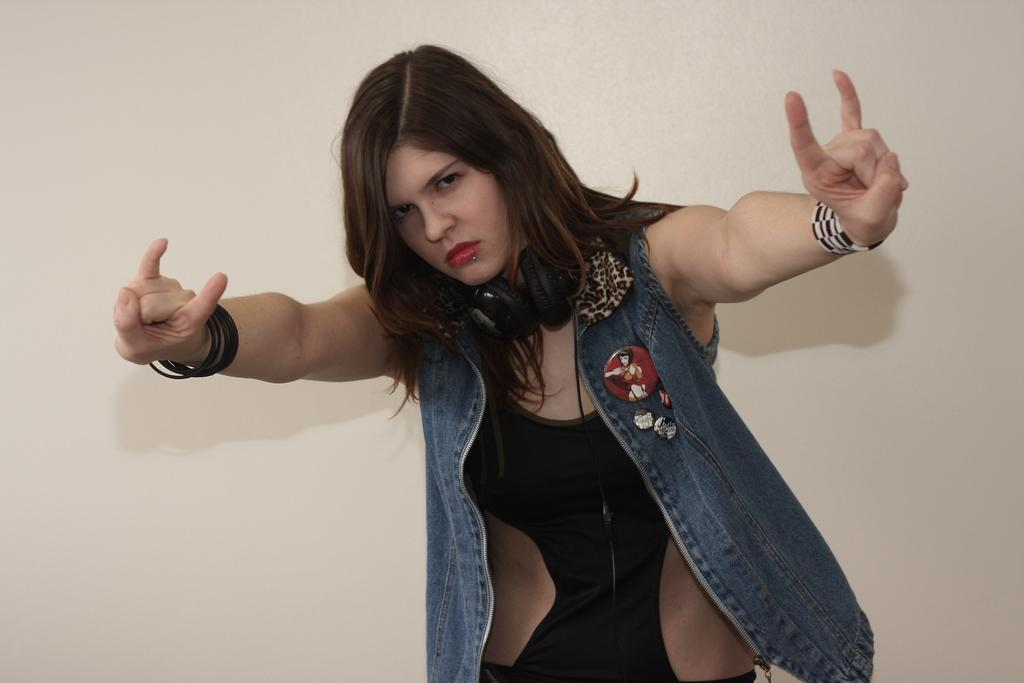Who is the main subject in the image? There is a woman in the image. What is the woman doing in the image? The woman is standing. What is the woman wearing in the image? The woman is wearing a jacket and bangles. What can be seen in the background of the image? There is a wall in the background of the image. What type of cord is the woman holding in the image? There is no cord present in the image. 